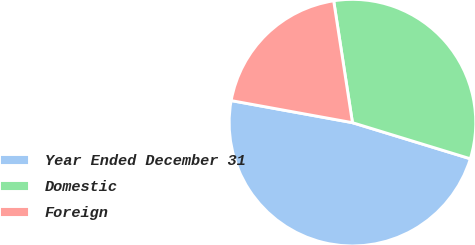Convert chart. <chart><loc_0><loc_0><loc_500><loc_500><pie_chart><fcel>Year Ended December 31<fcel>Domestic<fcel>Foreign<nl><fcel>48.13%<fcel>32.16%<fcel>19.7%<nl></chart> 